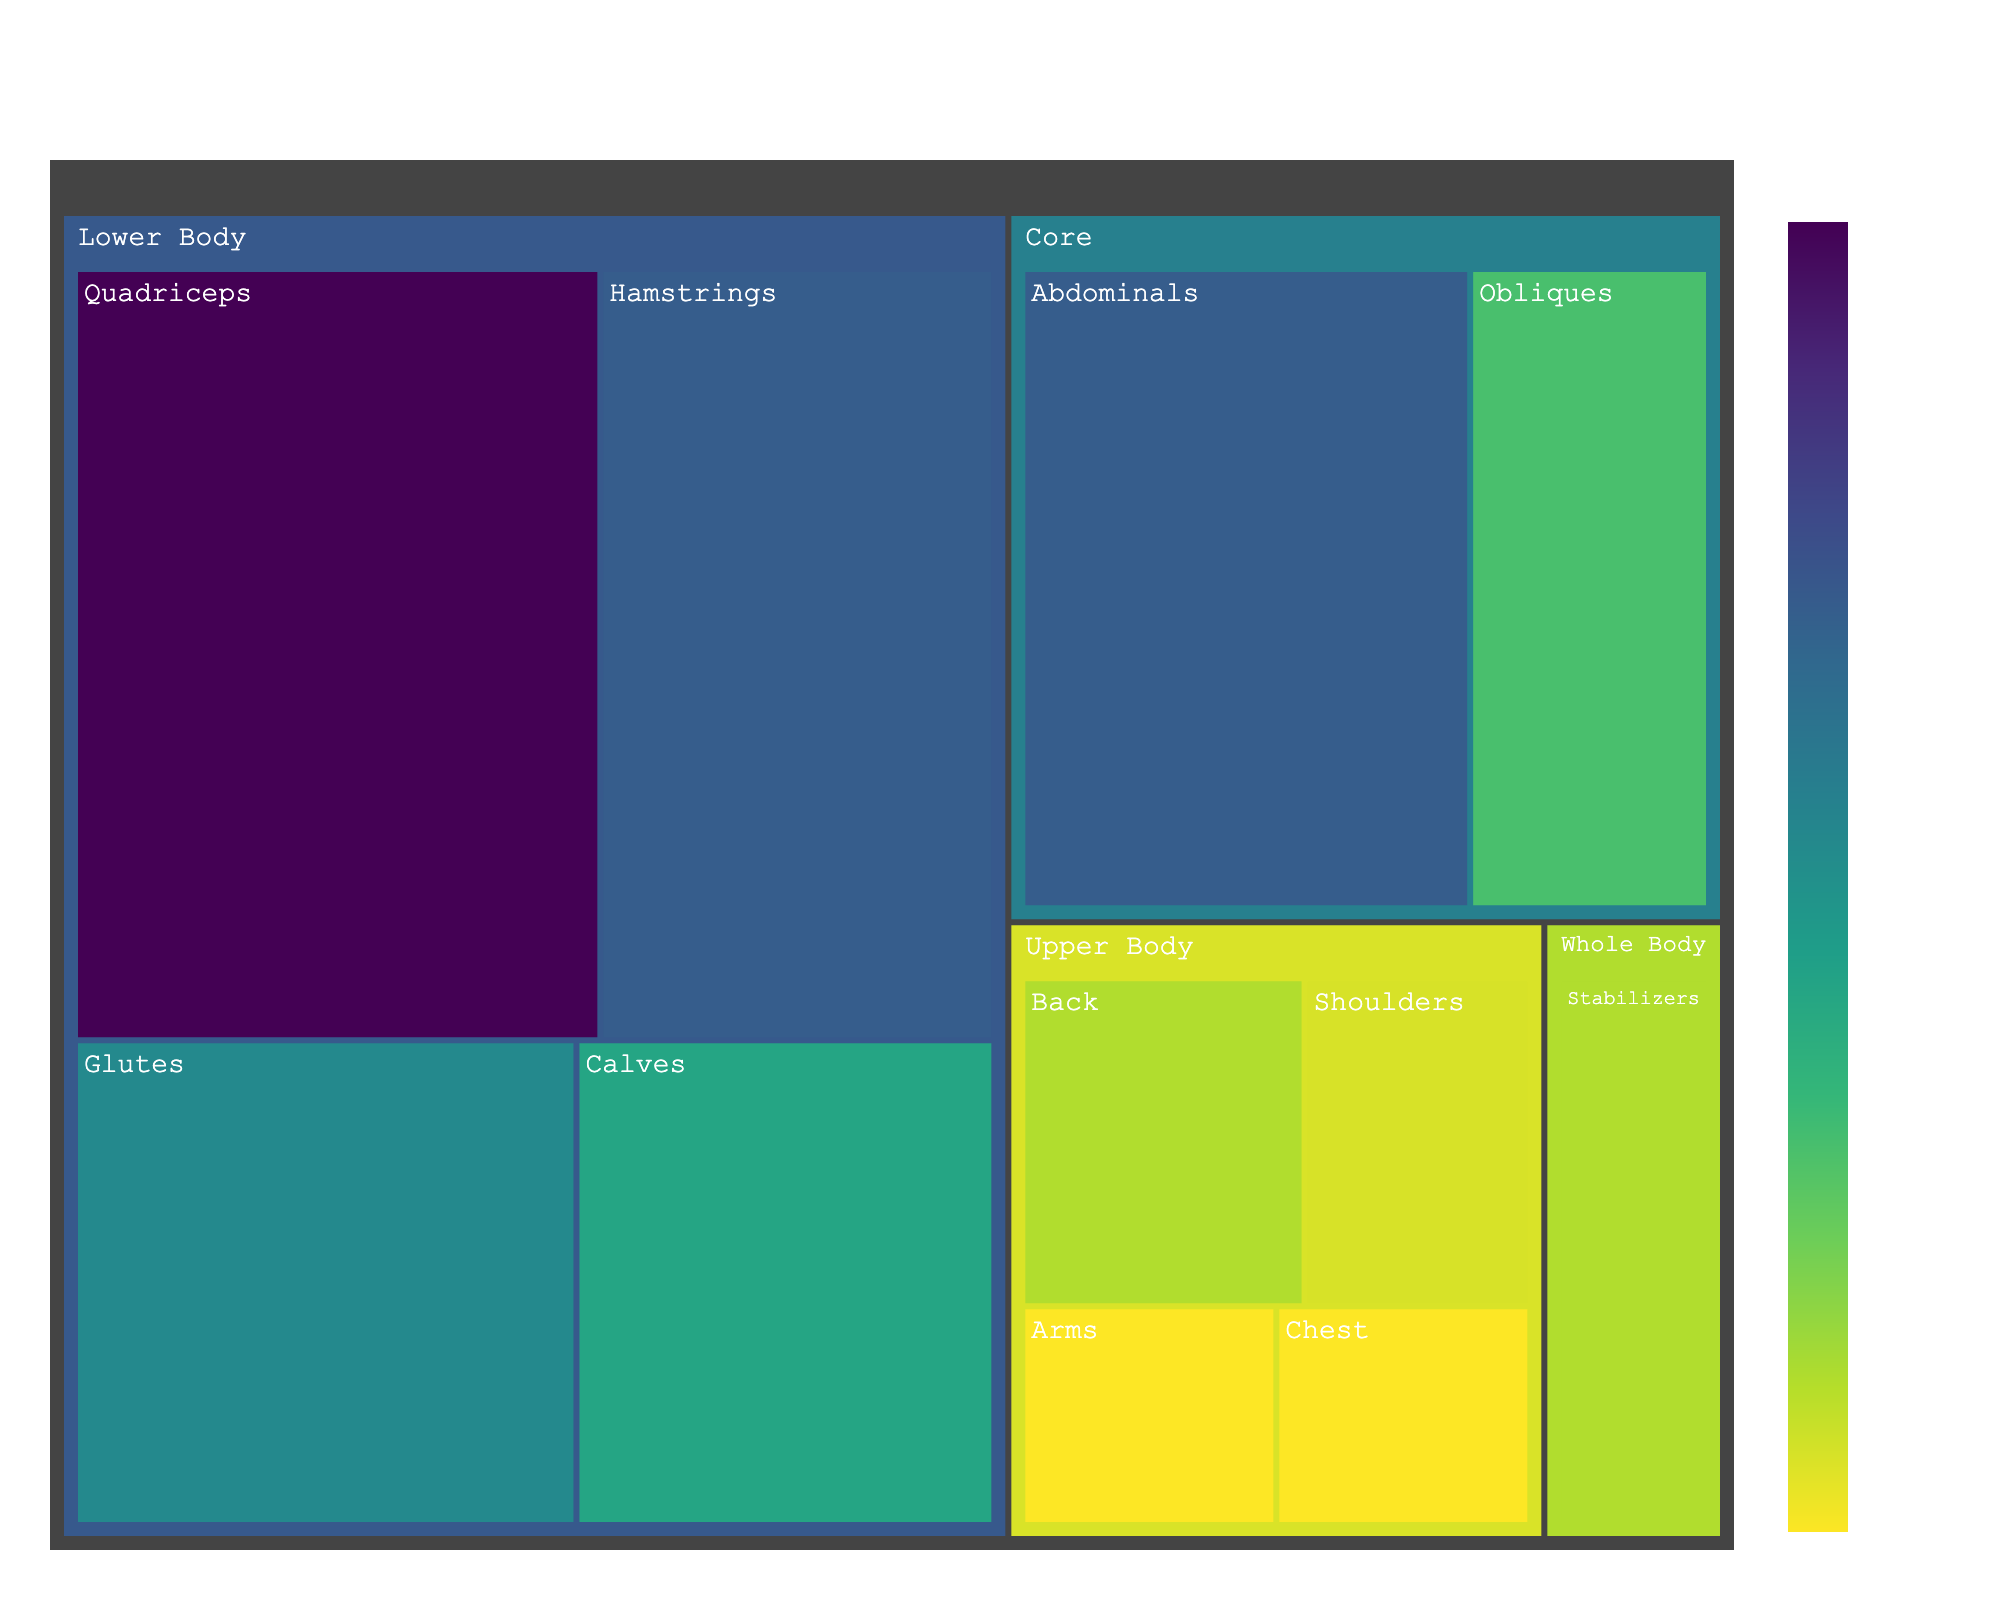How many muscle groups are targeted in the Lower Body region? Count the number of distinct muscle groups listed under the 'Lower Body' region in the treemap
Answer: 4 Which muscle group has the highest percentage in the Core region? Identify the muscle group with the largest percentage value under the 'Core' region
Answer: Abdominals What is the total percentage of the Lower Body muscle groups combined? Add the percentages of all muscle groups under 'Lower Body' (20 + 15 + 10 + 12)
Answer: 57 Which body region has the least percentage of muscle targeting? Compare the sum of percentages for each 'Body Region' and identify the lowest total
Answer: Upper Body What is the difference in percentage between the Glutes and Hamstrings muscles? Subtract the percentage of Hamstrings from that of Glutes (15 - 12)
Answer: 3 How much percentage is focused on the Upper Body compared to the Whole Body? Calculate the sum of percentages for 'Upper Body' (5 + 3 + 4 + 3) and 'Whole Body' (5), then compare
Answer: Upper Body is 15% more Which muscle group in the Upper Body has the highest percentage? Identify the muscle group with the largest percentage value under the 'Upper Body' region
Answer: Back Which muscle group contributes equally in percentage to Stabilizers in the Whole Body? Identify muscle groups across all regions that have the same percentage value as Stabilizers (5%) in the 'Whole Body'
Answer: Back What percentage of the Core region is devoted to Obliques? Note the percentage value for the 'Obliques' muscle group under the 'Core' region
Answer: 8 Which body region targets the highest total percentage of muscle groups based on the treemap? Compare the sum of all percentages within each 'Body Region' and identify the highest total
Answer: Lower Body 